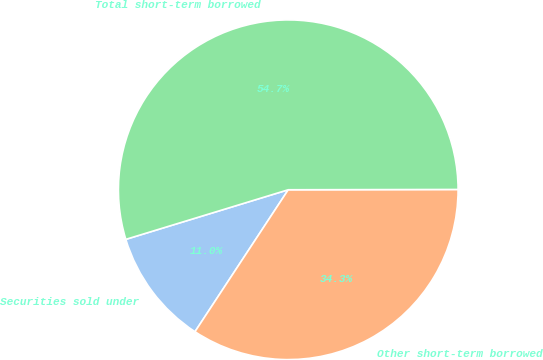<chart> <loc_0><loc_0><loc_500><loc_500><pie_chart><fcel>Securities sold under<fcel>Other short-term borrowed<fcel>Total short-term borrowed<nl><fcel>11.03%<fcel>34.28%<fcel>54.69%<nl></chart> 